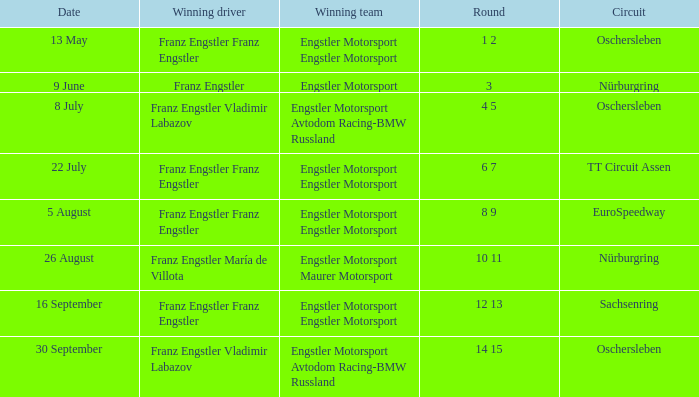Who is the Winning Driver that has a Winning team of Engstler Motorsport Engstler Motorsport and also the Date 22 July? Franz Engstler Franz Engstler. 